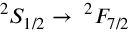<formula> <loc_0><loc_0><loc_500><loc_500>^ { 2 } S _ { 1 / 2 } \to \, ^ { 2 } F _ { 7 / 2 }</formula> 